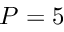<formula> <loc_0><loc_0><loc_500><loc_500>P = 5</formula> 